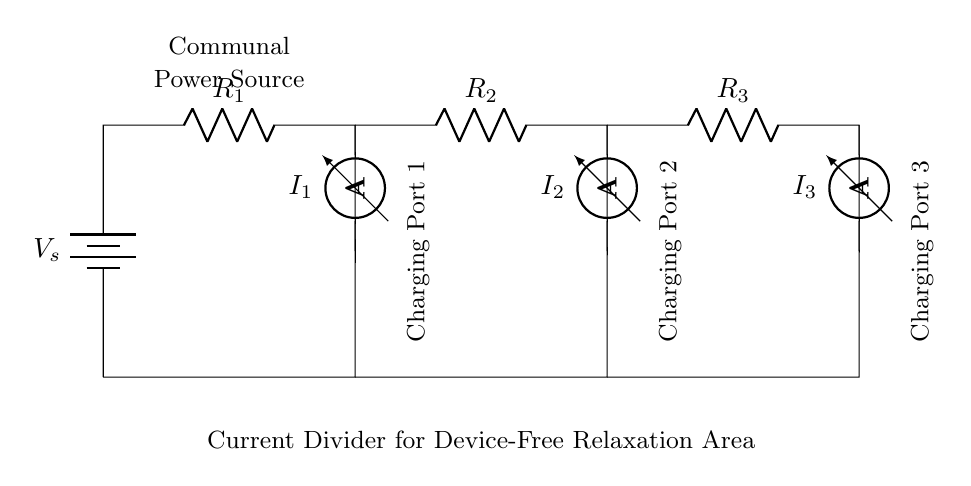What is the total resistance in the circuit? The total resistance can be calculated using the formula for parallel resistances: 1/R_total = 1/R_1 + 1/R_2 + 1/R_3. You would add the reciprocals of the individual resistances and then take the reciprocal of that sum to find the total resistance.
Answer: R_total What are the three current measurements indicated in the circuit? The circuit features three ammeters that indicate the currents I_1, I_2, and I_3 flowing through resistors R_1, R_2, and R_3, respectively, and each ammeter corresponds to a specific charging port.
Answer: I_1, I_2, I_3 Which component provides the voltage source in this circuit? The component providing the voltage source is a battery, which is indicated as V_s in the circuit diagram. It establishes the necessary potential difference for current to flow through the various paths.
Answer: Battery What is the function of the current divider in this setup? The current divider distributes the input current (coming from the power source) amongst multiple parallel branches, allowing for charging multiple devices at different ports while maintaining effective current management.
Answer: Current divider How does the current through each port compare? Using the current divider rule, the current flowing through each port is inversely proportional to its resistance. Lower resistance results in higher current through that branch, which should be calculated for I_1, I_2, and I_3 based on their respective resistances.
Answer: Inversely proportional to resistance 